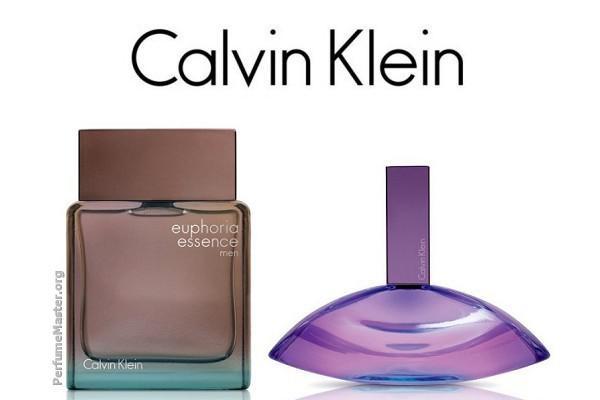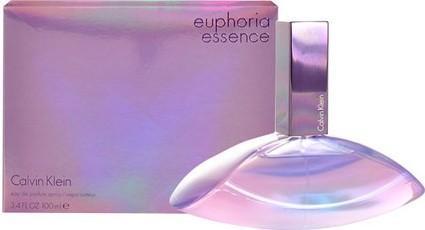The first image is the image on the left, the second image is the image on the right. Examine the images to the left and right. Is the description "The top of the lid of a purple bottle is visible in the image on the left." accurate? Answer yes or no. No. 